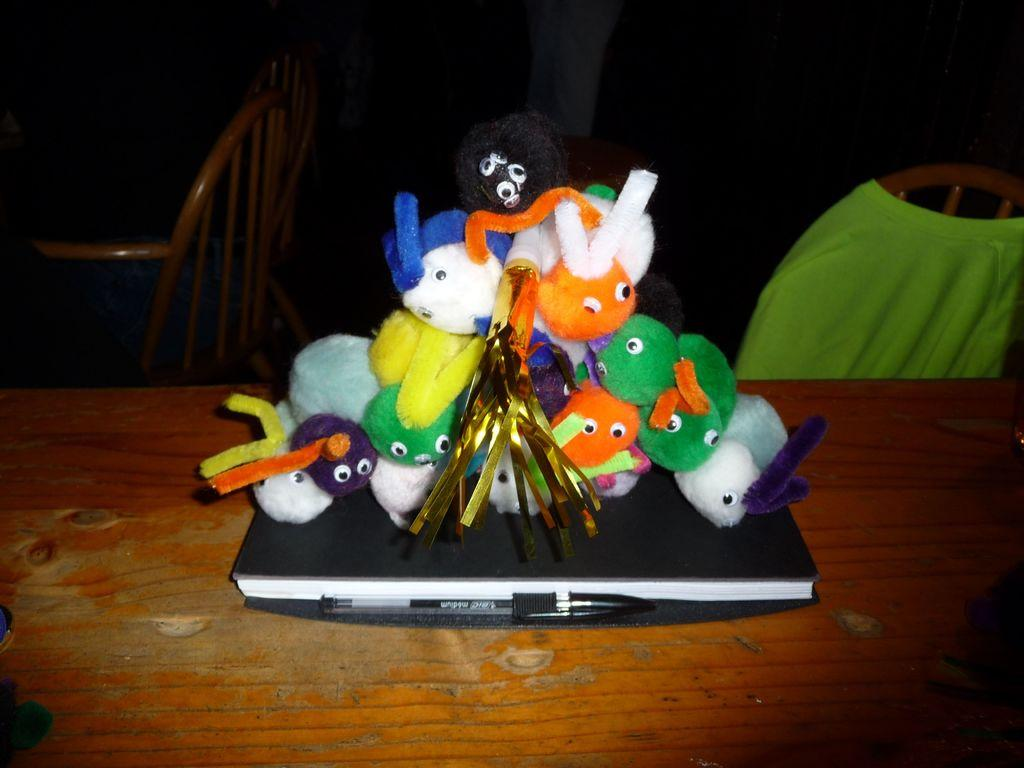What piece of furniture is present in the image? There is a table in the image. What object related to reading is on the table? There is a book on the table. What writing instrument is on the table? There is a pen on the table. What type of items are also present on the table? There are toys on the table. Can you describe the background of the image? There are chairs in the background on both the right and left sides. What type of calculator is being used by the grandmother in the image? There is no grandmother or calculator present in the image. 